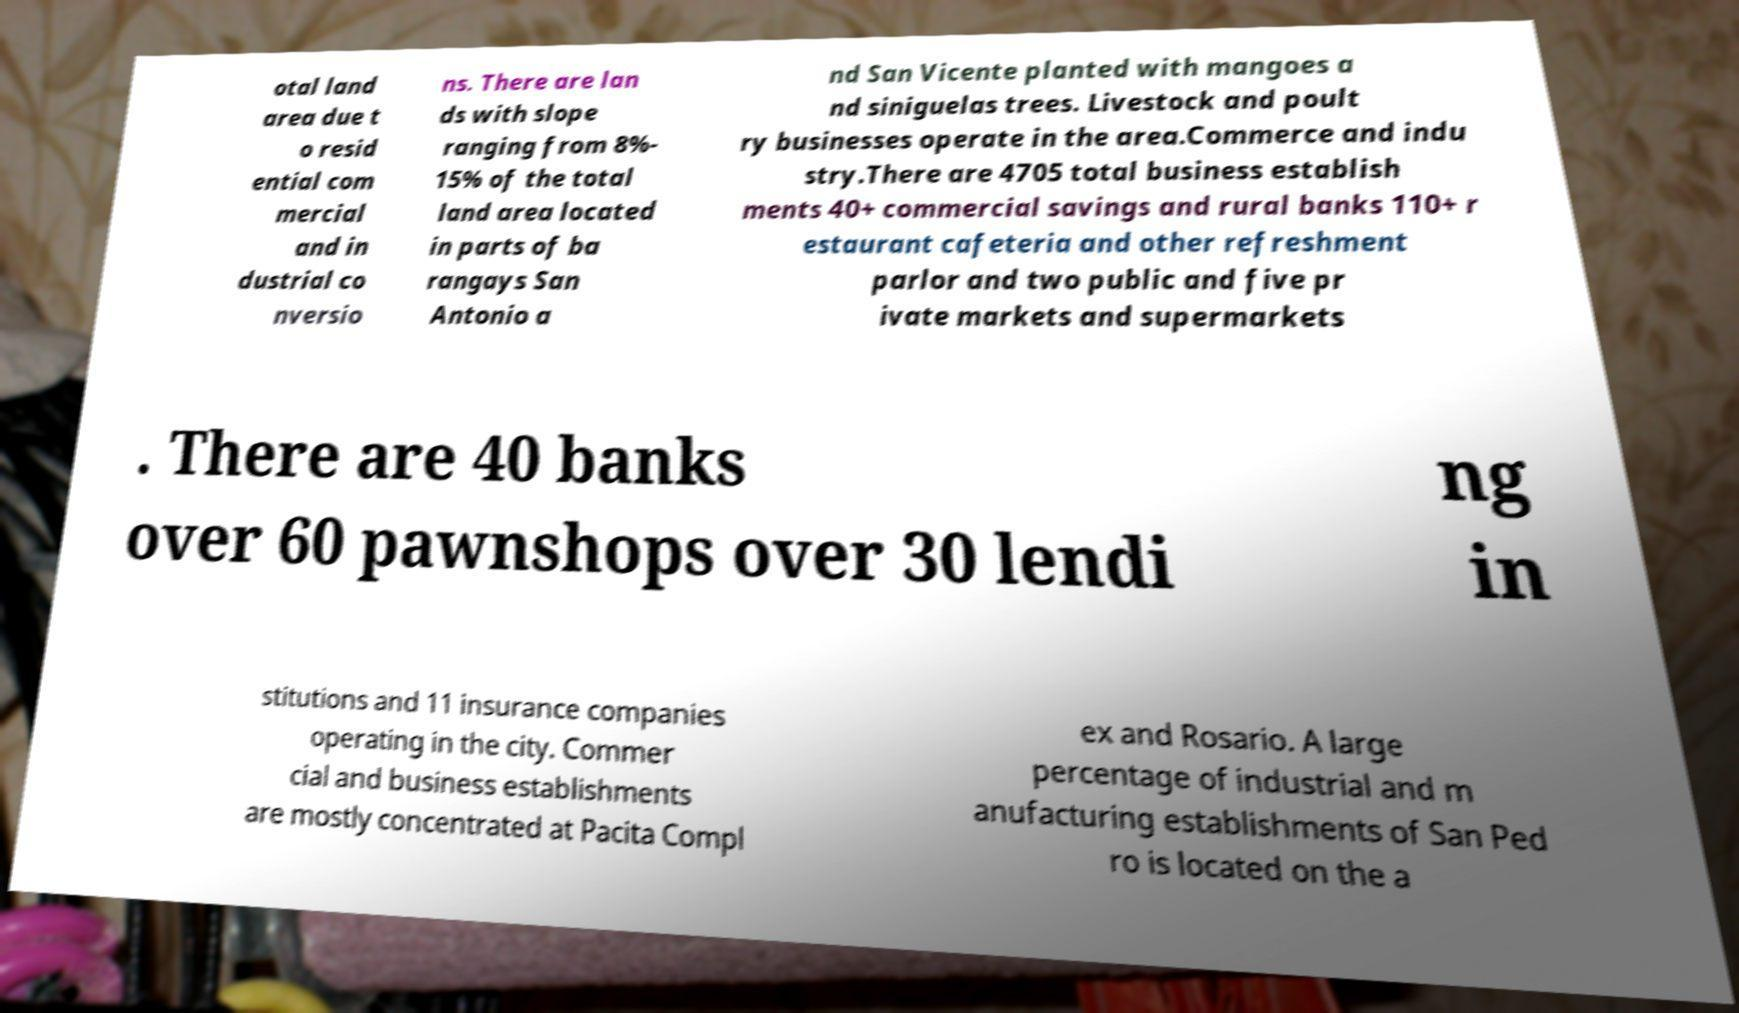Could you assist in decoding the text presented in this image and type it out clearly? otal land area due t o resid ential com mercial and in dustrial co nversio ns. There are lan ds with slope ranging from 8%- 15% of the total land area located in parts of ba rangays San Antonio a nd San Vicente planted with mangoes a nd siniguelas trees. Livestock and poult ry businesses operate in the area.Commerce and indu stry.There are 4705 total business establish ments 40+ commercial savings and rural banks 110+ r estaurant cafeteria and other refreshment parlor and two public and five pr ivate markets and supermarkets . There are 40 banks over 60 pawnshops over 30 lendi ng in stitutions and 11 insurance companies operating in the city. Commer cial and business establishments are mostly concentrated at Pacita Compl ex and Rosario. A large percentage of industrial and m anufacturing establishments of San Ped ro is located on the a 